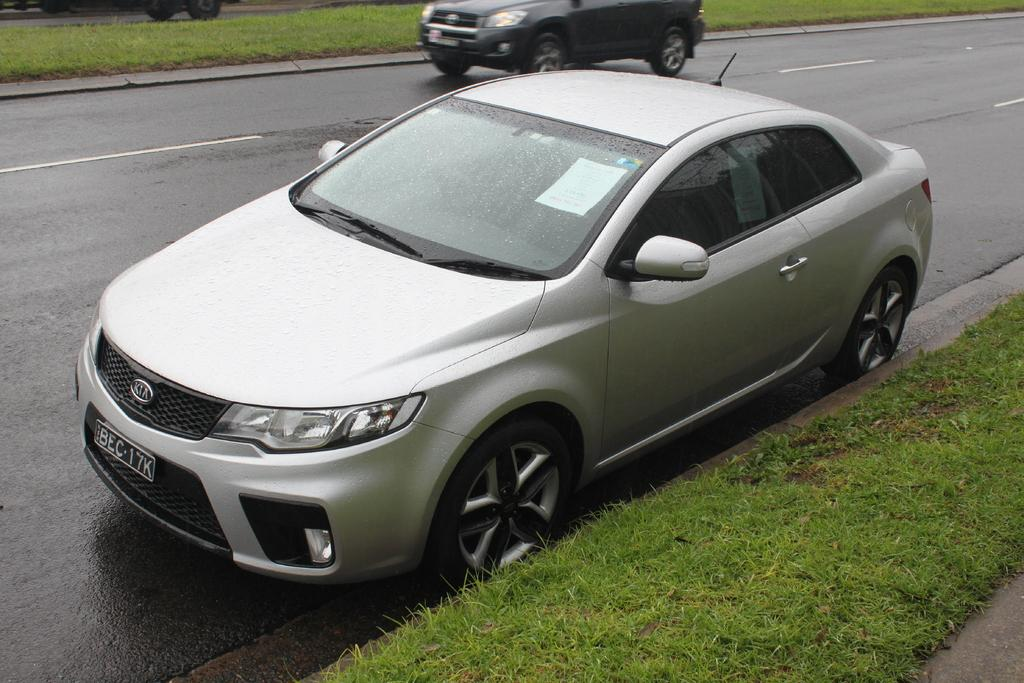What is the main feature of the image? There is a road in the image. Are there any vehicles on the road? Yes, there are two cars on the road. What type of vegetation is visible at the bottom of the image? There is grass at the bottom of the image. Can you describe the weather condition based on the image? The presence of droplets of water on the car mirror suggests that it might have been raining or that the car was recently washed. Where is the quicksand located in the image? There is no quicksand present in the image. What type of fruit is hanging from the tree in the image? There is no tree or fruit visible in the image. 